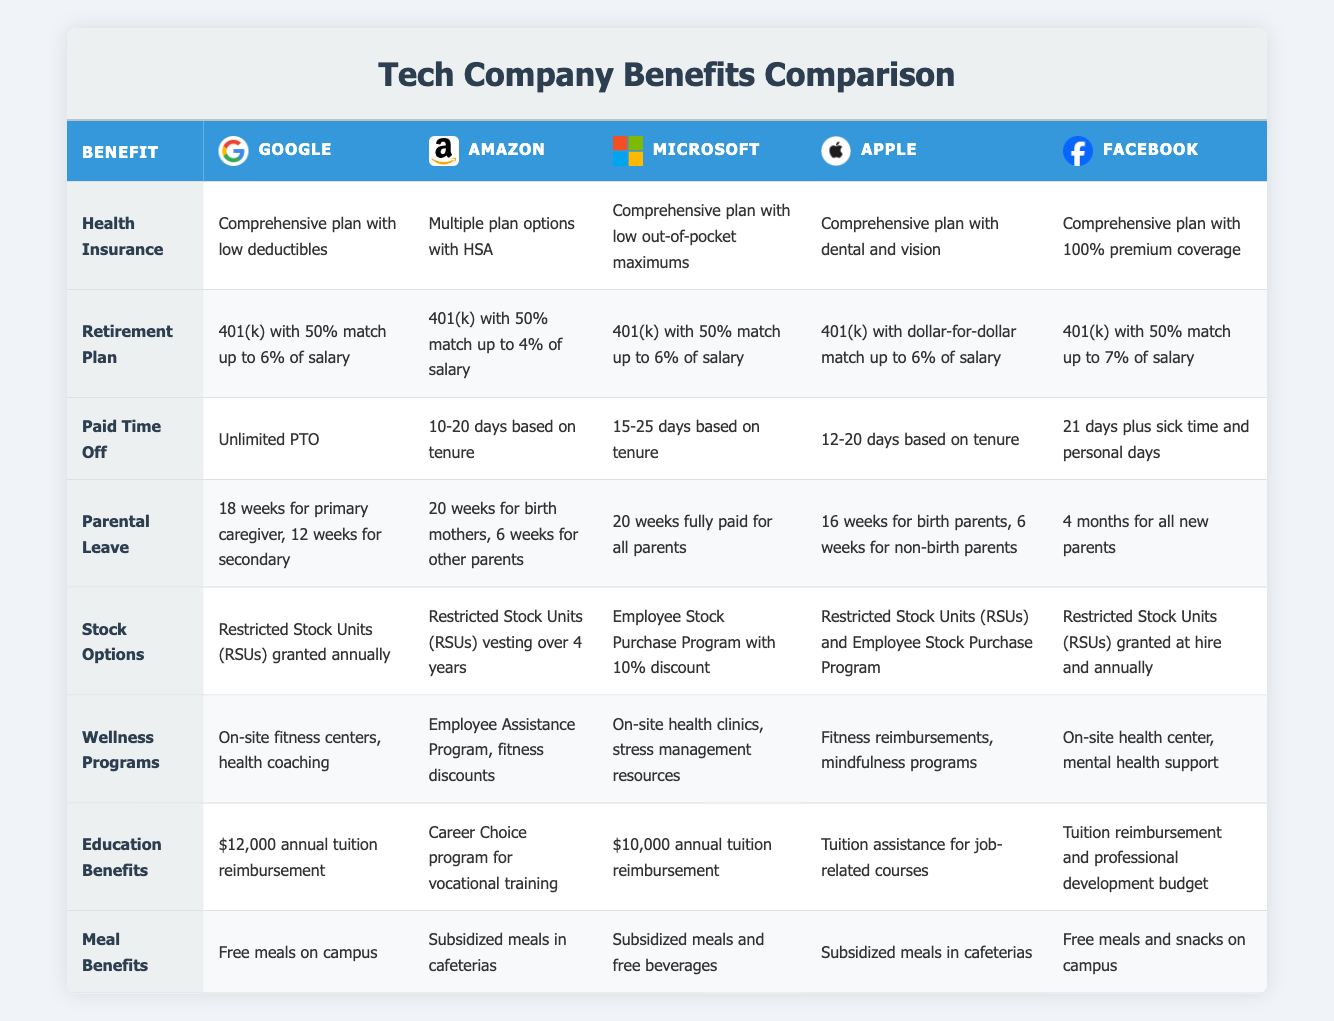What are the parental leave policies for Amazon? Amazon offers 20 weeks of parental leave for birth mothers and 6 weeks for other parents, as stated in the table.
Answer: 20 weeks for birth mothers, 6 weeks for other parents Which company offers unlimited paid time off? The table shows that Google provides unlimited paid time off, making it unique among the companies listed.
Answer: Google Do all companies provide health insurance? Yes, every company in the table outlines a health insurance plan, confirming that they all offer this benefit.
Answer: Yes How much is the annual tuition reimbursement at Google compared to Microsoft? Google offers $12,000 for annual tuition reimbursement while Microsoft provides $10,000. The difference is $2,000, with Google offering more.
Answer: $2,000 Which company has the most paid time off days at a minimum? According to the table, Facebook has a minimum of 21 days of paid time off, which is the highest among the listed companies.
Answer: Facebook Are wellness programs offered by all companies? No, the table includes wellness program details for all companies, but the nature of the programs varies, with some having more extensive offerings than others.
Answer: No What is the average cooldown period for stock vesting among these companies? The stock options for Amazon and Microsoft are specified as 4 years and include information that others grant stock units annually or at hire. By considering the variations, Amazon represents the extended period of 4 years.
Answer: 4 years If you combine Facebook's parental leave with Microsoft's, how many weeks of total parental leave do those two companies offer collectively? Facebook provides 16 weeks of parental leave for birth parents and 6 weeks for non-birth parents, while Microsoft offers 20 weeks for all parents. Summing these gives 16 + 20 = 36 weeks or 16 + 6 = 22 weeks for non-birth parents at Facebook.
Answer: 36 weeks (birth parents), 22 weeks (non-birth parents) How many companies provide stock options through a program? The table indicates that four companies (Microsoft, Apple, Amazon, and Facebook) mention specific stock option programs, suggesting a structured approach.
Answer: 4 companies 